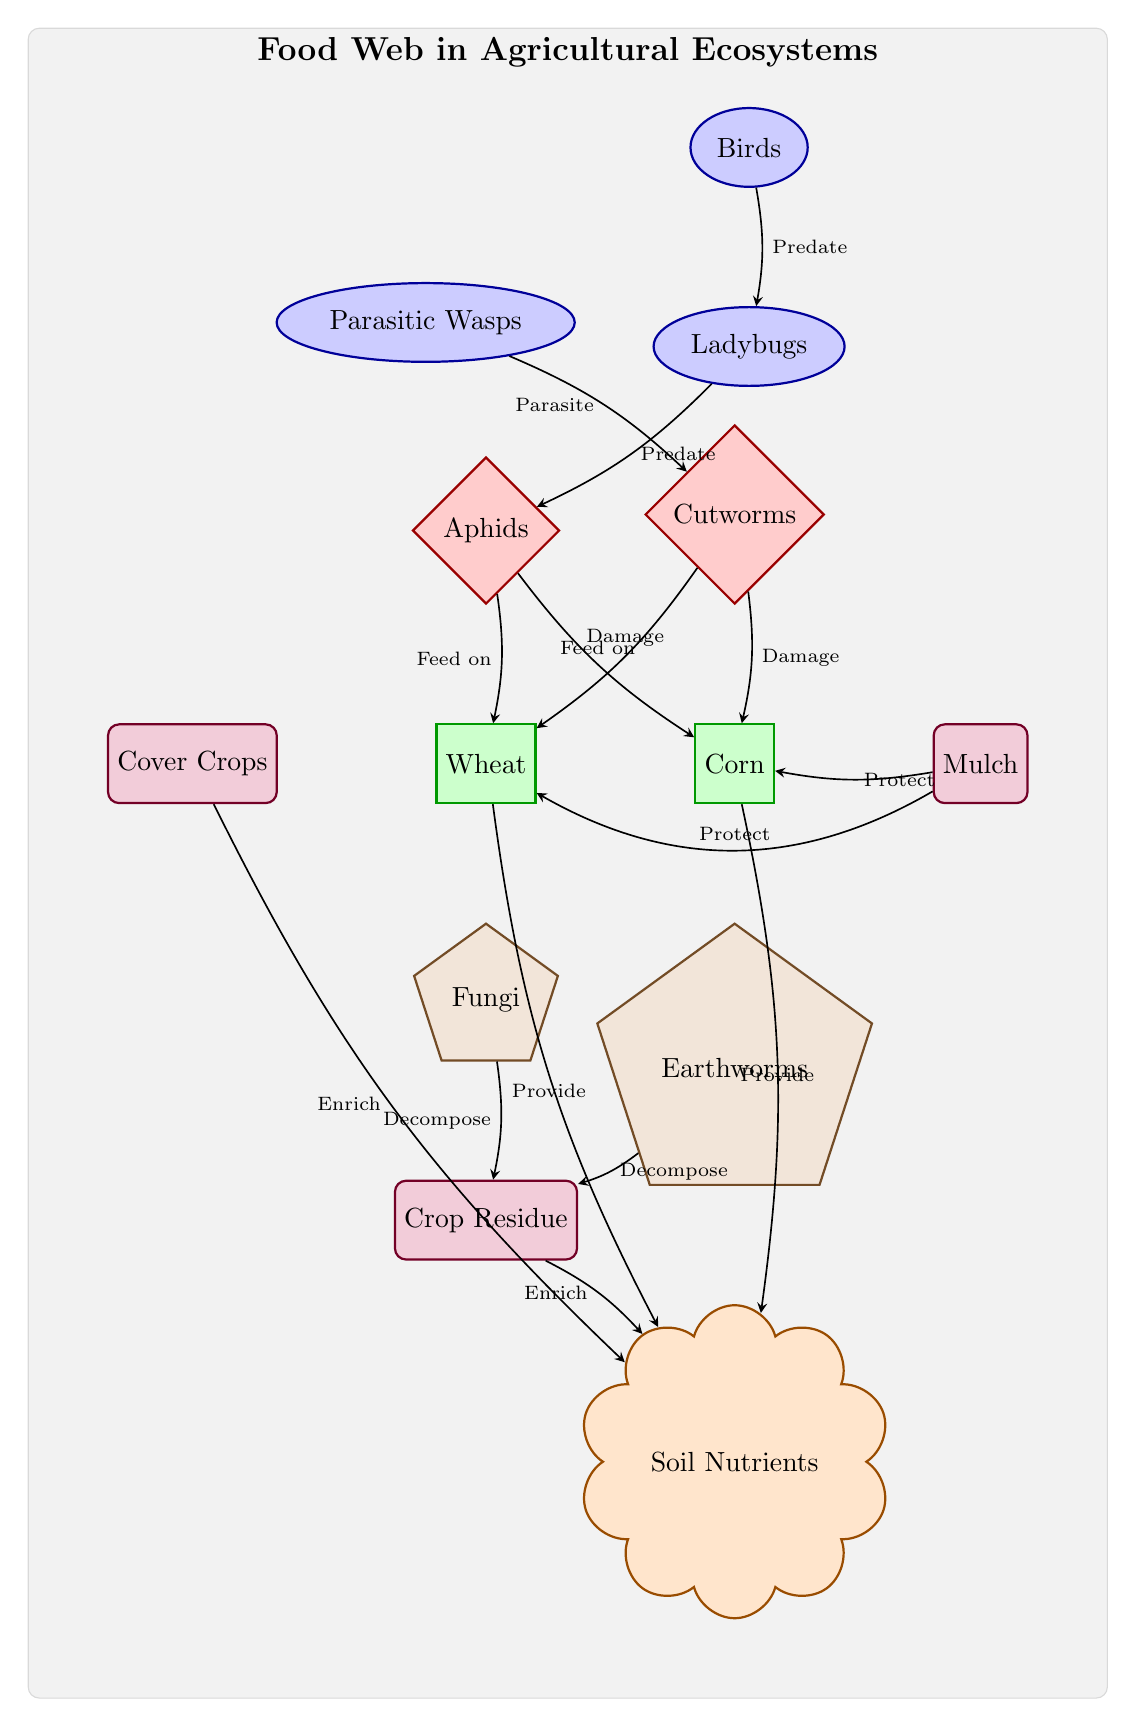What is the relationship between aphids and wheat? In the diagram, there is an edge directed from the node representing aphids to the node representing wheat, labeled "Feed on". This indicates that aphids feed on wheat as part of the food web.
Answer: Feed on How many decomposers are shown in the diagram? The decomposition roles are represented by two nodes: fungi and earthworms. Thus, counting these nodes gives us a total of two decomposers in the diagram.
Answer: 2 Which beneficial practice is indicated to protect corn? The node representing mulch has an edge directed to the corn node, labeled "Protect". This specifies that mulch is a beneficial practice that provides protection for corn against various threats.
Answer: Mulch What do ladybugs do in this food web? The edge from the ladybugs node to the aphids node is labeled "Predate". This shows that ladybugs act as predators of aphids, situating them within the food web as beneficial insects helping to control pests.
Answer: Predate How do crop residues contribute to the ecosystem? The edge leading from the residue node to the nutrients node is labeled "Enrich". This means crop residues have a role in enriching the soil nutrients, supporting the overall fertility of the agricultural ecosystem.
Answer: Enrich What type of organisms are cutworms classified as in the diagram? The node for cutworms is represented in a diamond shape and is filled with red, which indicates it is a pest within the agricultural ecosystem.
Answer: Pest What is the main purpose of cover crops in the food web? The edge from the cover node to the nutrients node is labeled "Enrich". This denotes that cover crops are used to enrich nutrients in the soil, enhancing the agricultural system's sustainability.
Answer: Enrich How many predators are there in this food web? The diagram includes three predator nodes: ladybugs, parasitic wasps, and birds. Counting these nodes gives us a total of three predators present.
Answer: 3 